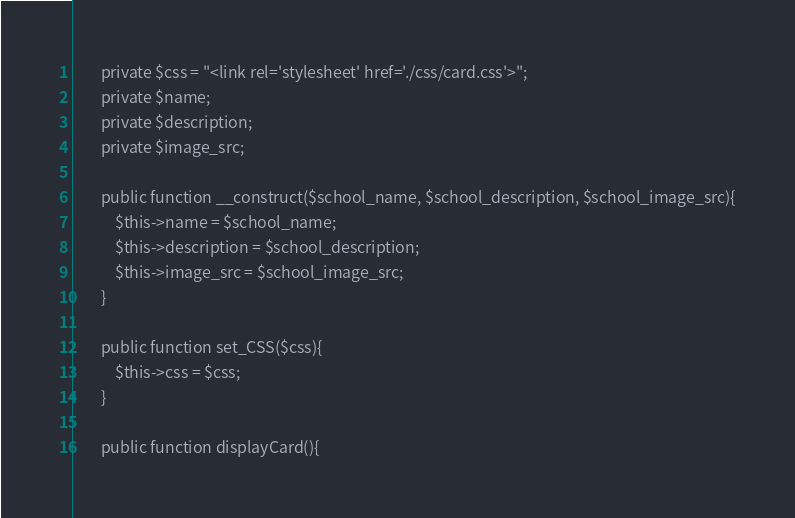<code> <loc_0><loc_0><loc_500><loc_500><_PHP_>        private $css = "<link rel='stylesheet' href='./css/card.css'>";
        private $name;
        private $description;
        private $image_src;

        public function __construct($school_name, $school_description, $school_image_src){
            $this->name = $school_name;
            $this->description = $school_description;
            $this->image_src = $school_image_src;
        }

        public function set_CSS($css){
            $this->css = $css;
        }

        public function displayCard(){</code> 